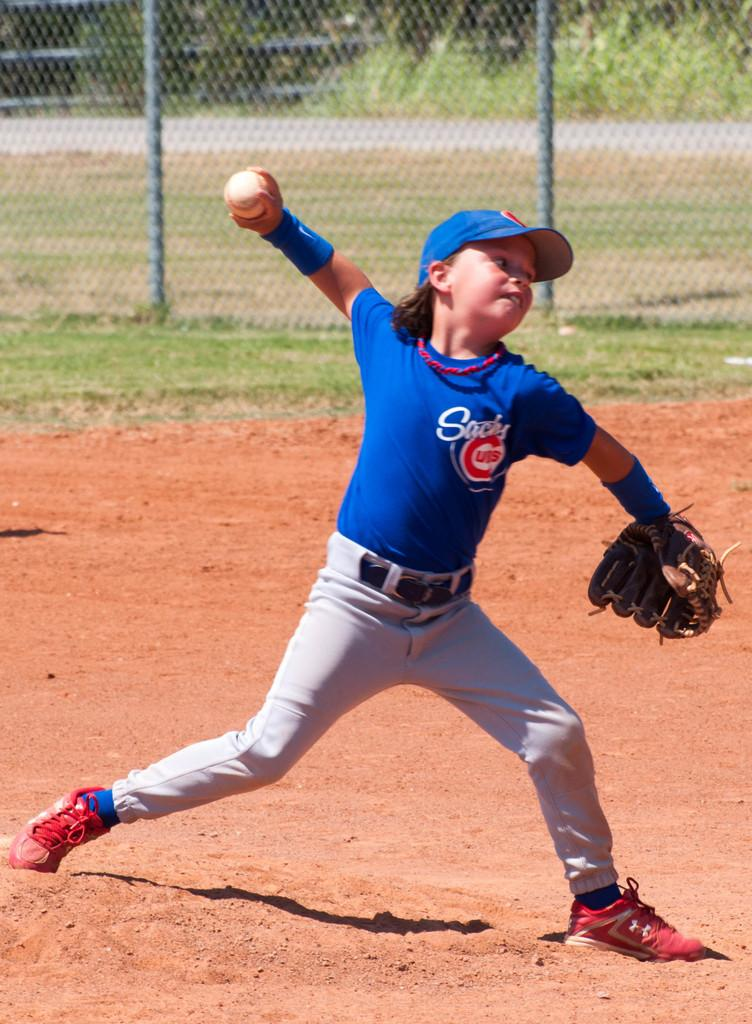Provide a one-sentence caption for the provided image. A young baseball player wearing a Cubs shirt is pitching a baseball. 